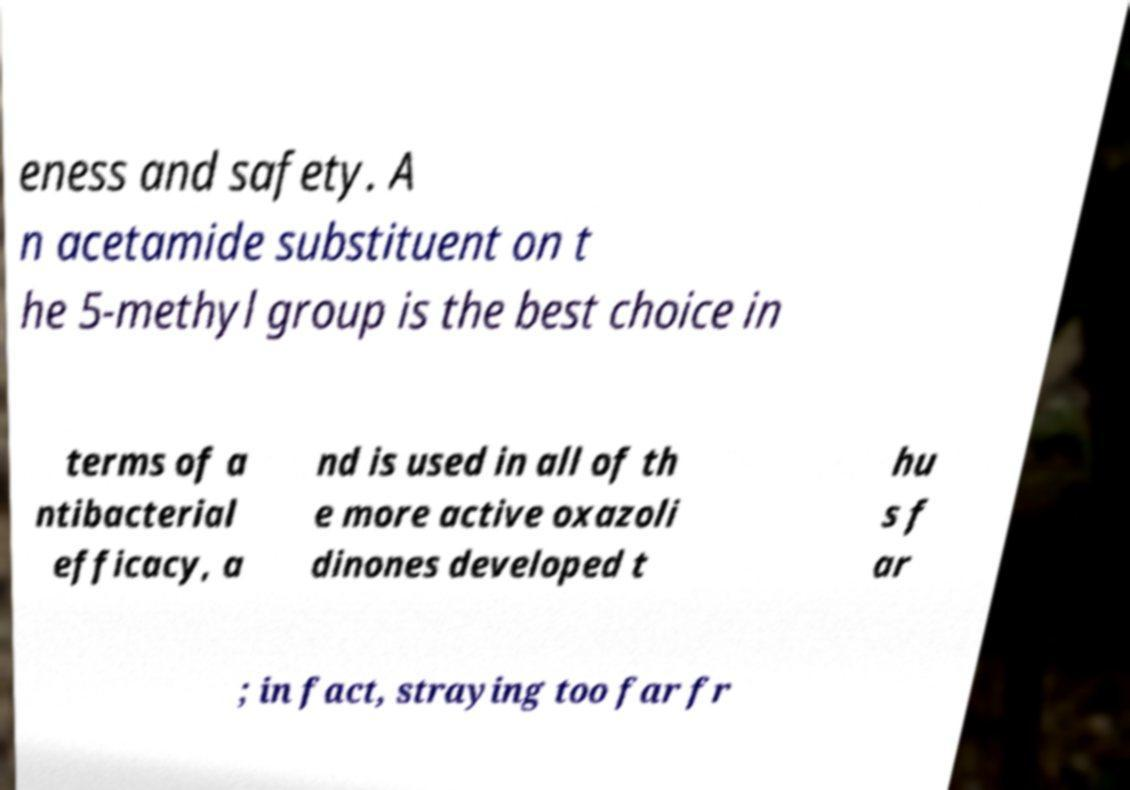Please identify and transcribe the text found in this image. eness and safety. A n acetamide substituent on t he 5-methyl group is the best choice in terms of a ntibacterial efficacy, a nd is used in all of th e more active oxazoli dinones developed t hu s f ar ; in fact, straying too far fr 